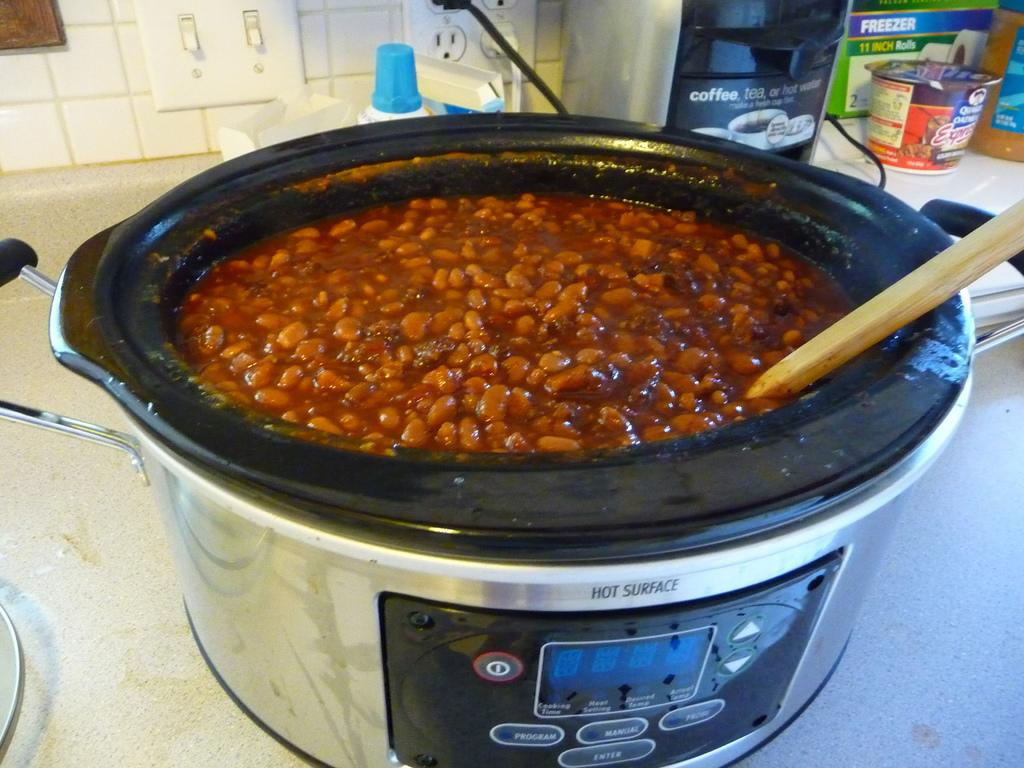<image>
Write a terse but informative summary of the picture. A crockpot full of baked beansd says HOT SURFACE at the top 